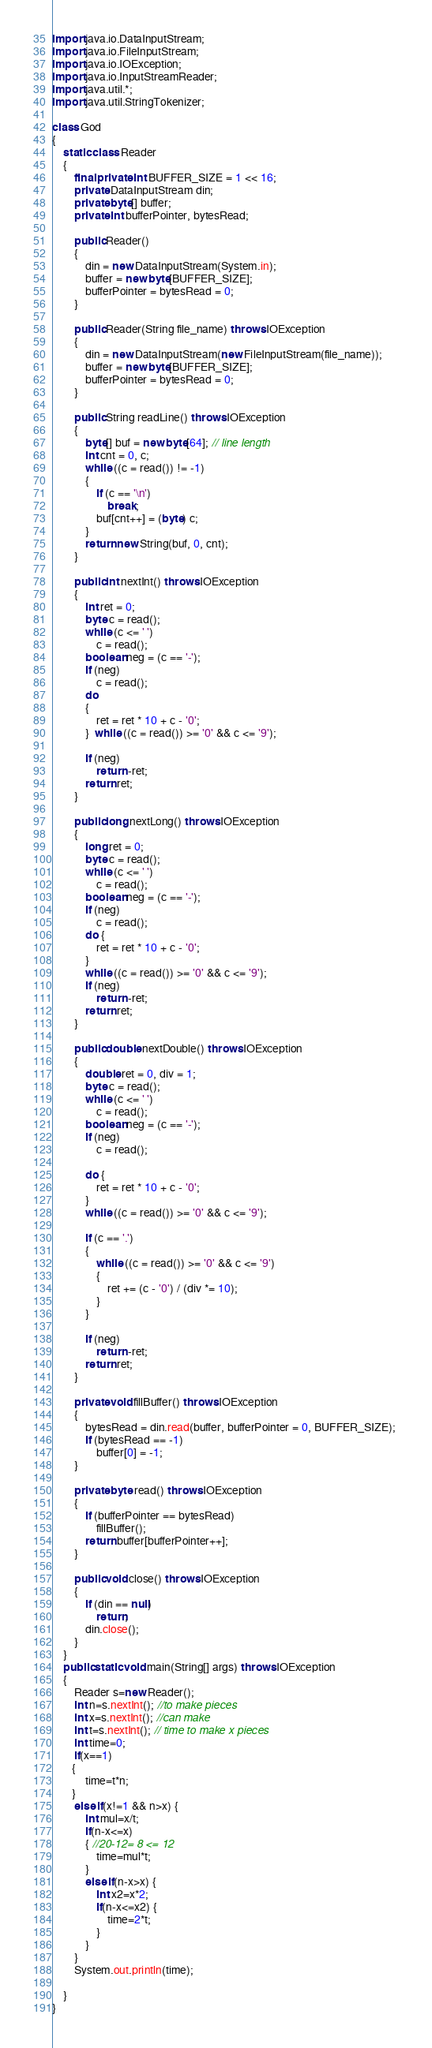Convert code to text. <code><loc_0><loc_0><loc_500><loc_500><_Java_>import java.io.DataInputStream; 
import java.io.FileInputStream; 
import java.io.IOException; 
import java.io.InputStreamReader; 
import java.util.*; 
import java.util.StringTokenizer; 
  
class God
{ 
    static class Reader 
    { 
        final private int BUFFER_SIZE = 1 << 16; 
        private DataInputStream din; 
        private byte[] buffer; 
        private int bufferPointer, bytesRead; 
  
        public Reader() 
        { 
            din = new DataInputStream(System.in); 
            buffer = new byte[BUFFER_SIZE]; 
            bufferPointer = bytesRead = 0; 
        } 
  
        public Reader(String file_name) throws IOException 
        { 
            din = new DataInputStream(new FileInputStream(file_name)); 
            buffer = new byte[BUFFER_SIZE]; 
            bufferPointer = bytesRead = 0; 
        } 
  
        public String readLine() throws IOException 
        { 
            byte[] buf = new byte[64]; // line length 
            int cnt = 0, c; 
            while ((c = read()) != -1) 
            { 
                if (c == '\n') 
                    break; 
                buf[cnt++] = (byte) c; 
            } 
            return new String(buf, 0, cnt); 
        } 
  
        public int nextInt() throws IOException 
        { 
            int ret = 0; 
            byte c = read(); 
            while (c <= ' ') 
                c = read(); 
            boolean neg = (c == '-'); 
            if (neg) 
                c = read(); 
            do
            { 
                ret = ret * 10 + c - '0'; 
            }  while ((c = read()) >= '0' && c <= '9'); 
  
            if (neg) 
                return -ret; 
            return ret; 
        } 
  
        public long nextLong() throws IOException 
        { 
            long ret = 0; 
            byte c = read(); 
            while (c <= ' ') 
                c = read(); 
            boolean neg = (c == '-'); 
            if (neg) 
                c = read(); 
            do { 
                ret = ret * 10 + c - '0'; 
            } 
            while ((c = read()) >= '0' && c <= '9'); 
            if (neg) 
                return -ret; 
            return ret; 
        } 
  
        public double nextDouble() throws IOException 
        { 
            double ret = 0, div = 1; 
            byte c = read(); 
            while (c <= ' ') 
                c = read(); 
            boolean neg = (c == '-'); 
            if (neg) 
                c = read(); 
  
            do { 
                ret = ret * 10 + c - '0'; 
            } 
            while ((c = read()) >= '0' && c <= '9'); 
  
            if (c == '.') 
            { 
                while ((c = read()) >= '0' && c <= '9') 
                { 
                    ret += (c - '0') / (div *= 10); 
                } 
            } 
  
            if (neg) 
                return -ret; 
            return ret; 
        } 
  
        private void fillBuffer() throws IOException 
        { 
            bytesRead = din.read(buffer, bufferPointer = 0, BUFFER_SIZE); 
            if (bytesRead == -1) 
                buffer[0] = -1; 
        } 
  
        private byte read() throws IOException 
        { 
            if (bufferPointer == bytesRead) 
                fillBuffer(); 
            return buffer[bufferPointer++]; 
        } 
  
        public void close() throws IOException 
        { 
            if (din == null) 
                return; 
            din.close(); 
        } 
    } 
    public static void main(String[] args) throws IOException 
    { 
        Reader s=new Reader(); 
        int n=s.nextInt(); //to make pieces
        int x=s.nextInt(); //can make
        int t=s.nextInt(); // time to make x pieces
        int time=0;
        if(x==1)
       {
    	    time=t*n;
       }
        else if(x!=1 && n>x) {
        	int mul=x/t;
        	if(n-x<=x) 
        	{ //20-12= 8 <= 12
        		time=mul*t;
        	}
        	else if(n-x>x) {
        		int x2=x*2;
        		if(n-x<=x2) {
        			time=2*t;
        		}
        	}
        }
        System.out.println(time);
       
    } 
} </code> 